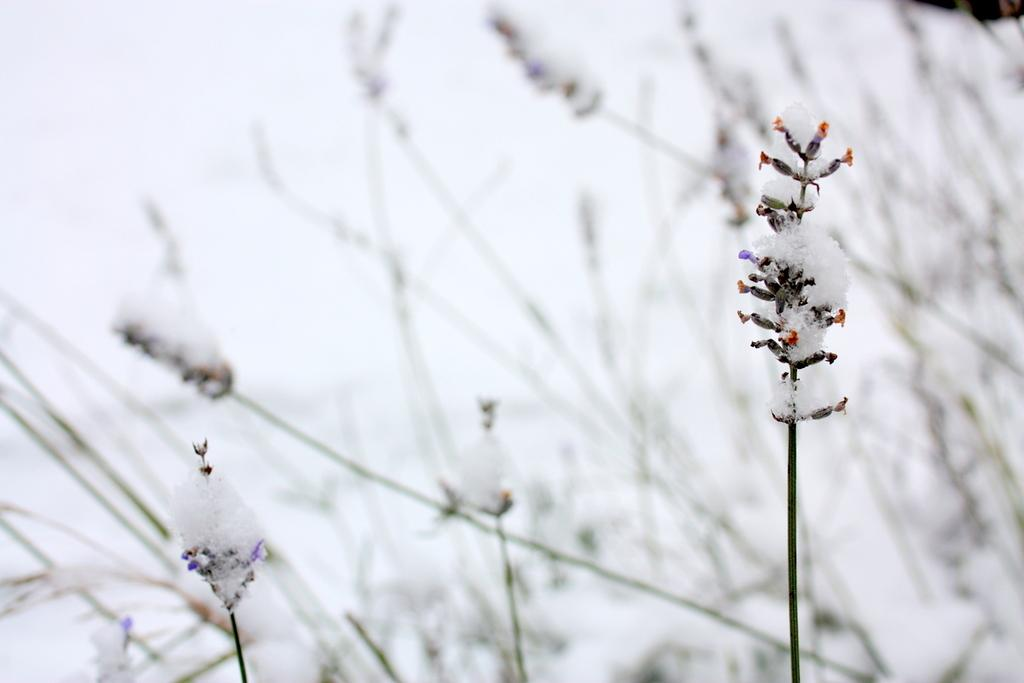What type of living organisms can be seen in the image? The image contains plants. What is the condition of the plants in the image? There is ice on the plants. What can be seen in the background of the image? There is a sky visible in the background of the image. What type of flowers can be seen in the image? There is no mention of flowers in the image; it contains plants with ice on them. Is there a cook visible in the image? There is no cook present in the image. 